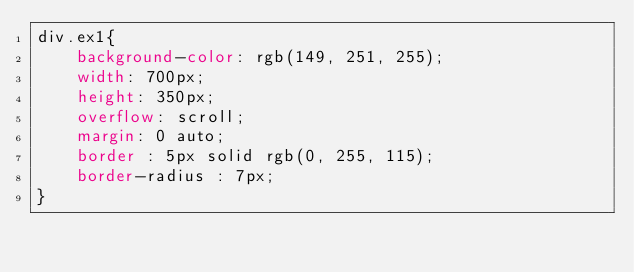Convert code to text. <code><loc_0><loc_0><loc_500><loc_500><_CSS_>div.ex1{
    background-color: rgb(149, 251, 255);
    width: 700px;
    height: 350px;
    overflow: scroll;
    margin: 0 auto;
    border : 5px solid rgb(0, 255, 115);
    border-radius : 7px;
}


        
    </code> 